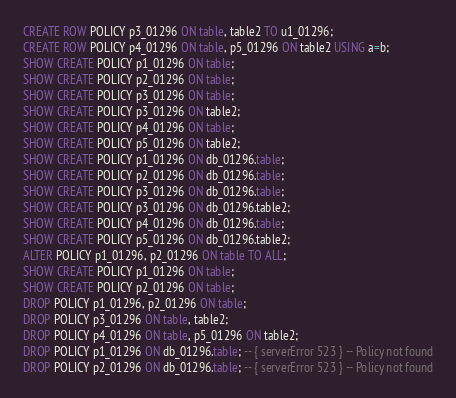<code> <loc_0><loc_0><loc_500><loc_500><_SQL_>CREATE ROW POLICY p3_01296 ON table, table2 TO u1_01296;
CREATE ROW POLICY p4_01296 ON table, p5_01296 ON table2 USING a=b;
SHOW CREATE POLICY p1_01296 ON table;
SHOW CREATE POLICY p2_01296 ON table;
SHOW CREATE POLICY p3_01296 ON table;
SHOW CREATE POLICY p3_01296 ON table2;
SHOW CREATE POLICY p4_01296 ON table;
SHOW CREATE POLICY p5_01296 ON table2;
SHOW CREATE POLICY p1_01296 ON db_01296.table;
SHOW CREATE POLICY p2_01296 ON db_01296.table;
SHOW CREATE POLICY p3_01296 ON db_01296.table;
SHOW CREATE POLICY p3_01296 ON db_01296.table2;
SHOW CREATE POLICY p4_01296 ON db_01296.table;
SHOW CREATE POLICY p5_01296 ON db_01296.table2;
ALTER POLICY p1_01296, p2_01296 ON table TO ALL;
SHOW CREATE POLICY p1_01296 ON table;
SHOW CREATE POLICY p2_01296 ON table;
DROP POLICY p1_01296, p2_01296 ON table;
DROP POLICY p3_01296 ON table, table2;
DROP POLICY p4_01296 ON table, p5_01296 ON table2;
DROP POLICY p1_01296 ON db_01296.table; -- { serverError 523 } -- Policy not found
DROP POLICY p2_01296 ON db_01296.table; -- { serverError 523 } -- Policy not found</code> 